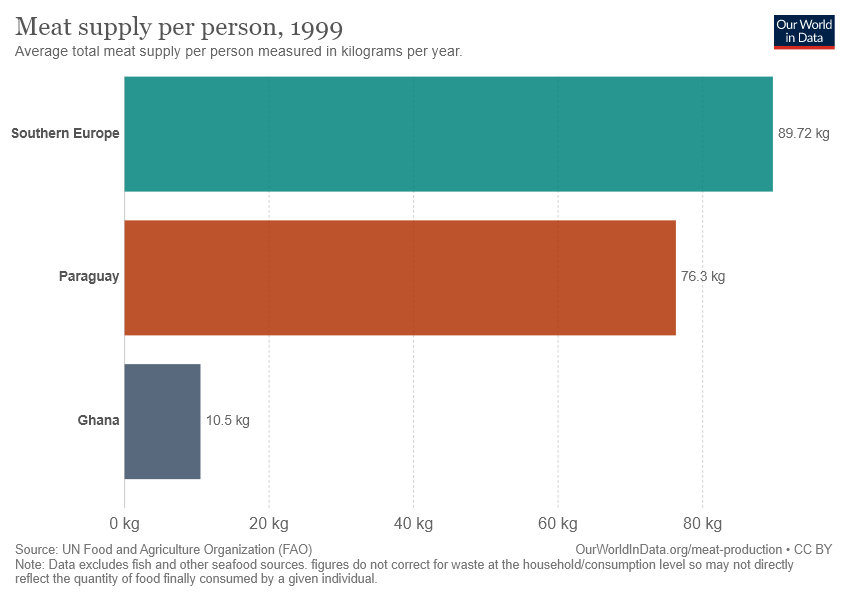Specify some key components in this picture. The average total meat supply per person in Ghana is approximately 10.5. The value of Paraguay and Ghana differ by 65.8. 